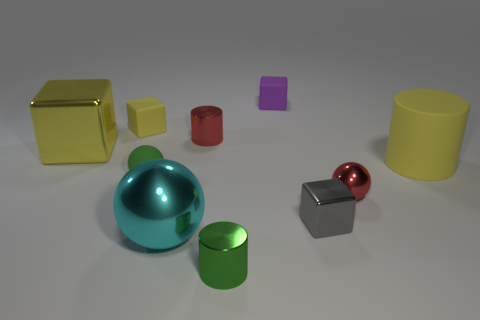Subtract all blue cubes. Subtract all blue balls. How many cubes are left? 4 Subtract all spheres. How many objects are left? 7 Subtract all small yellow cubes. Subtract all tiny gray metallic blocks. How many objects are left? 8 Add 4 green metallic cylinders. How many green metallic cylinders are left? 5 Add 3 tiny brown cubes. How many tiny brown cubes exist? 3 Subtract 0 yellow spheres. How many objects are left? 10 